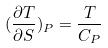<formula> <loc_0><loc_0><loc_500><loc_500>( \frac { \partial T } { \partial S } ) _ { P } = \frac { T } { C _ { P } }</formula> 